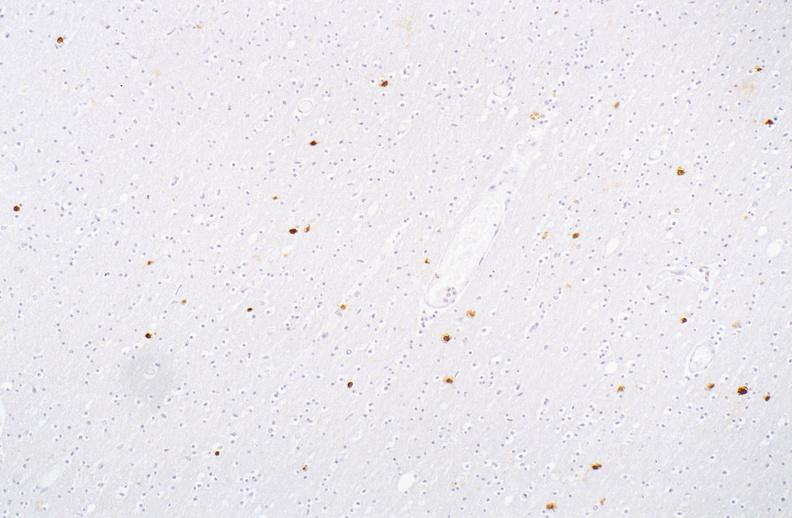s cardiovascular present?
Answer the question using a single word or phrase. No 